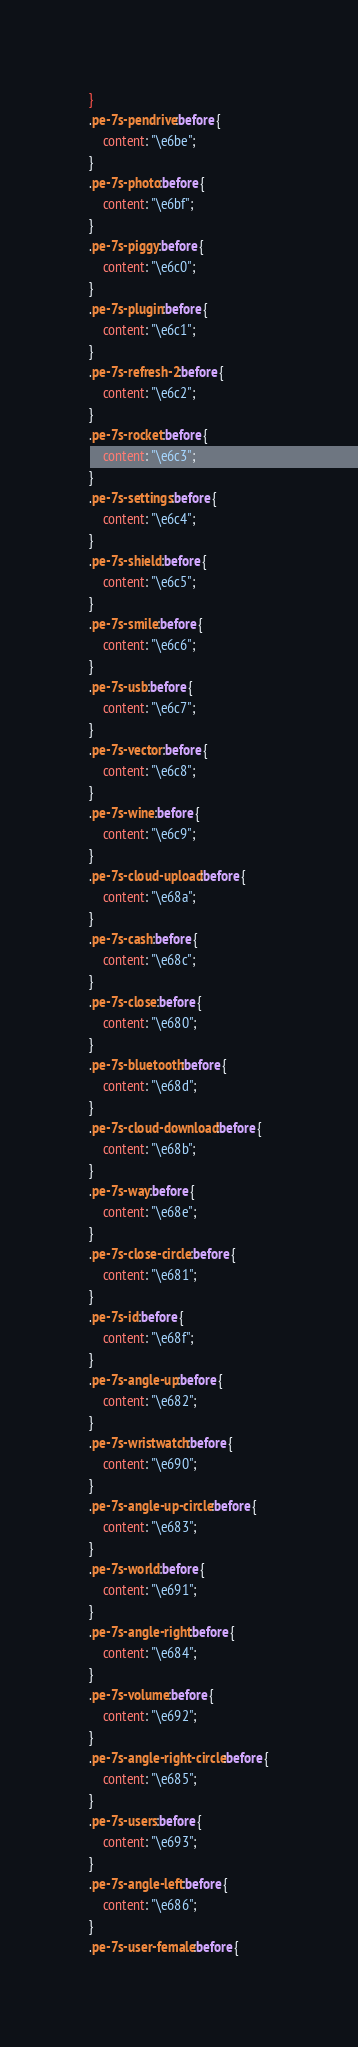<code> <loc_0><loc_0><loc_500><loc_500><_CSS_>}
.pe-7s-pendrive:before {
	content: "\e6be";
}
.pe-7s-photo:before {
	content: "\e6bf";
}
.pe-7s-piggy:before {
	content: "\e6c0";
}
.pe-7s-plugin:before {
	content: "\e6c1";
}
.pe-7s-refresh-2:before {
	content: "\e6c2";
}
.pe-7s-rocket:before {
	content: "\e6c3";
}
.pe-7s-settings:before {
	content: "\e6c4";
}
.pe-7s-shield:before {
	content: "\e6c5";
}
.pe-7s-smile:before {
	content: "\e6c6";
}
.pe-7s-usb:before {
	content: "\e6c7";
}
.pe-7s-vector:before {
	content: "\e6c8";
}
.pe-7s-wine:before {
	content: "\e6c9";
}
.pe-7s-cloud-upload:before {
	content: "\e68a";
}
.pe-7s-cash:before {
	content: "\e68c";
}
.pe-7s-close:before {
	content: "\e680";
}
.pe-7s-bluetooth:before {
	content: "\e68d";
}
.pe-7s-cloud-download:before {
	content: "\e68b";
}
.pe-7s-way:before {
	content: "\e68e";
}
.pe-7s-close-circle:before {
	content: "\e681";
}
.pe-7s-id:before {
	content: "\e68f";
}
.pe-7s-angle-up:before {
	content: "\e682";
}
.pe-7s-wristwatch:before {
	content: "\e690";
}
.pe-7s-angle-up-circle:before {
	content: "\e683";
}
.pe-7s-world:before {
	content: "\e691";
}
.pe-7s-angle-right:before {
	content: "\e684";
}
.pe-7s-volume:before {
	content: "\e692";
}
.pe-7s-angle-right-circle:before {
	content: "\e685";
}
.pe-7s-users:before {
	content: "\e693";
}
.pe-7s-angle-left:before {
	content: "\e686";
}
.pe-7s-user-female:before {</code> 